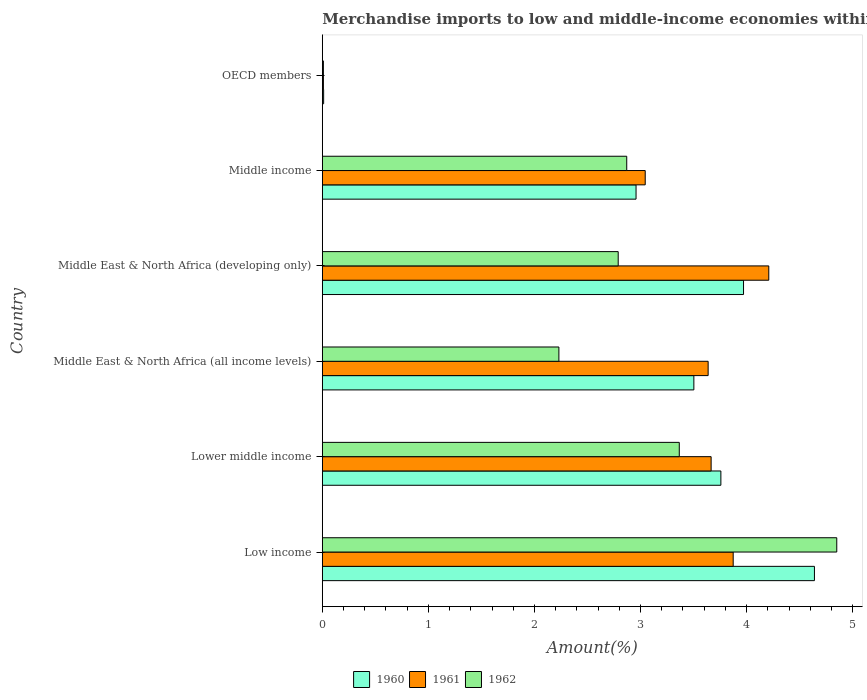How many different coloured bars are there?
Keep it short and to the point. 3. How many groups of bars are there?
Ensure brevity in your answer.  6. Are the number of bars on each tick of the Y-axis equal?
Ensure brevity in your answer.  Yes. How many bars are there on the 2nd tick from the top?
Offer a terse response. 3. In how many cases, is the number of bars for a given country not equal to the number of legend labels?
Give a very brief answer. 0. What is the percentage of amount earned from merchandise imports in 1962 in Lower middle income?
Ensure brevity in your answer.  3.37. Across all countries, what is the maximum percentage of amount earned from merchandise imports in 1960?
Your answer should be very brief. 4.64. Across all countries, what is the minimum percentage of amount earned from merchandise imports in 1960?
Ensure brevity in your answer.  0.01. In which country was the percentage of amount earned from merchandise imports in 1961 maximum?
Your response must be concise. Middle East & North Africa (developing only). In which country was the percentage of amount earned from merchandise imports in 1960 minimum?
Your response must be concise. OECD members. What is the total percentage of amount earned from merchandise imports in 1962 in the graph?
Make the answer very short. 16.11. What is the difference between the percentage of amount earned from merchandise imports in 1962 in Low income and that in OECD members?
Provide a short and direct response. 4.84. What is the difference between the percentage of amount earned from merchandise imports in 1961 in Middle East & North Africa (developing only) and the percentage of amount earned from merchandise imports in 1962 in OECD members?
Your answer should be very brief. 4.2. What is the average percentage of amount earned from merchandise imports in 1962 per country?
Make the answer very short. 2.69. What is the difference between the percentage of amount earned from merchandise imports in 1960 and percentage of amount earned from merchandise imports in 1962 in Lower middle income?
Your answer should be very brief. 0.39. What is the ratio of the percentage of amount earned from merchandise imports in 1962 in Lower middle income to that in Middle East & North Africa (developing only)?
Give a very brief answer. 1.21. Is the percentage of amount earned from merchandise imports in 1962 in Low income less than that in Middle East & North Africa (all income levels)?
Your answer should be very brief. No. What is the difference between the highest and the second highest percentage of amount earned from merchandise imports in 1960?
Keep it short and to the point. 0.67. What is the difference between the highest and the lowest percentage of amount earned from merchandise imports in 1961?
Keep it short and to the point. 4.2. Is the sum of the percentage of amount earned from merchandise imports in 1960 in Middle East & North Africa (all income levels) and OECD members greater than the maximum percentage of amount earned from merchandise imports in 1961 across all countries?
Ensure brevity in your answer.  No. Is it the case that in every country, the sum of the percentage of amount earned from merchandise imports in 1962 and percentage of amount earned from merchandise imports in 1961 is greater than the percentage of amount earned from merchandise imports in 1960?
Ensure brevity in your answer.  Yes. How many bars are there?
Your response must be concise. 18. Are all the bars in the graph horizontal?
Make the answer very short. Yes. How many countries are there in the graph?
Ensure brevity in your answer.  6. What is the difference between two consecutive major ticks on the X-axis?
Your answer should be very brief. 1. Does the graph contain grids?
Ensure brevity in your answer.  No. How many legend labels are there?
Provide a short and direct response. 3. What is the title of the graph?
Give a very brief answer. Merchandise imports to low and middle-income economies within region. What is the label or title of the X-axis?
Provide a short and direct response. Amount(%). What is the label or title of the Y-axis?
Provide a short and direct response. Country. What is the Amount(%) of 1960 in Low income?
Provide a short and direct response. 4.64. What is the Amount(%) of 1961 in Low income?
Make the answer very short. 3.87. What is the Amount(%) in 1962 in Low income?
Provide a succinct answer. 4.85. What is the Amount(%) of 1960 in Lower middle income?
Ensure brevity in your answer.  3.76. What is the Amount(%) of 1961 in Lower middle income?
Provide a succinct answer. 3.67. What is the Amount(%) of 1962 in Lower middle income?
Provide a succinct answer. 3.37. What is the Amount(%) in 1960 in Middle East & North Africa (all income levels)?
Give a very brief answer. 3.5. What is the Amount(%) in 1961 in Middle East & North Africa (all income levels)?
Offer a terse response. 3.64. What is the Amount(%) in 1962 in Middle East & North Africa (all income levels)?
Make the answer very short. 2.23. What is the Amount(%) of 1960 in Middle East & North Africa (developing only)?
Your answer should be compact. 3.97. What is the Amount(%) in 1961 in Middle East & North Africa (developing only)?
Your response must be concise. 4.21. What is the Amount(%) in 1962 in Middle East & North Africa (developing only)?
Provide a succinct answer. 2.79. What is the Amount(%) in 1960 in Middle income?
Offer a very short reply. 2.96. What is the Amount(%) of 1961 in Middle income?
Your answer should be compact. 3.04. What is the Amount(%) in 1962 in Middle income?
Provide a short and direct response. 2.87. What is the Amount(%) of 1960 in OECD members?
Your answer should be compact. 0.01. What is the Amount(%) in 1961 in OECD members?
Provide a succinct answer. 0.01. What is the Amount(%) of 1962 in OECD members?
Make the answer very short. 0.01. Across all countries, what is the maximum Amount(%) of 1960?
Offer a terse response. 4.64. Across all countries, what is the maximum Amount(%) of 1961?
Ensure brevity in your answer.  4.21. Across all countries, what is the maximum Amount(%) in 1962?
Provide a succinct answer. 4.85. Across all countries, what is the minimum Amount(%) in 1960?
Make the answer very short. 0.01. Across all countries, what is the minimum Amount(%) in 1961?
Your response must be concise. 0.01. Across all countries, what is the minimum Amount(%) of 1962?
Make the answer very short. 0.01. What is the total Amount(%) in 1960 in the graph?
Provide a short and direct response. 18.84. What is the total Amount(%) of 1961 in the graph?
Your response must be concise. 18.44. What is the total Amount(%) of 1962 in the graph?
Ensure brevity in your answer.  16.11. What is the difference between the Amount(%) in 1960 in Low income and that in Lower middle income?
Keep it short and to the point. 0.88. What is the difference between the Amount(%) in 1961 in Low income and that in Lower middle income?
Your answer should be compact. 0.21. What is the difference between the Amount(%) of 1962 in Low income and that in Lower middle income?
Keep it short and to the point. 1.48. What is the difference between the Amount(%) in 1960 in Low income and that in Middle East & North Africa (all income levels)?
Your answer should be compact. 1.14. What is the difference between the Amount(%) in 1961 in Low income and that in Middle East & North Africa (all income levels)?
Provide a succinct answer. 0.24. What is the difference between the Amount(%) of 1962 in Low income and that in Middle East & North Africa (all income levels)?
Your answer should be compact. 2.62. What is the difference between the Amount(%) of 1960 in Low income and that in Middle East & North Africa (developing only)?
Your answer should be very brief. 0.67. What is the difference between the Amount(%) in 1961 in Low income and that in Middle East & North Africa (developing only)?
Your response must be concise. -0.34. What is the difference between the Amount(%) in 1962 in Low income and that in Middle East & North Africa (developing only)?
Provide a short and direct response. 2.06. What is the difference between the Amount(%) in 1960 in Low income and that in Middle income?
Provide a succinct answer. 1.68. What is the difference between the Amount(%) of 1961 in Low income and that in Middle income?
Provide a short and direct response. 0.83. What is the difference between the Amount(%) in 1962 in Low income and that in Middle income?
Offer a terse response. 1.98. What is the difference between the Amount(%) in 1960 in Low income and that in OECD members?
Offer a very short reply. 4.63. What is the difference between the Amount(%) in 1961 in Low income and that in OECD members?
Make the answer very short. 3.86. What is the difference between the Amount(%) in 1962 in Low income and that in OECD members?
Offer a terse response. 4.84. What is the difference between the Amount(%) of 1960 in Lower middle income and that in Middle East & North Africa (all income levels)?
Offer a very short reply. 0.25. What is the difference between the Amount(%) of 1961 in Lower middle income and that in Middle East & North Africa (all income levels)?
Ensure brevity in your answer.  0.03. What is the difference between the Amount(%) of 1962 in Lower middle income and that in Middle East & North Africa (all income levels)?
Offer a terse response. 1.14. What is the difference between the Amount(%) of 1960 in Lower middle income and that in Middle East & North Africa (developing only)?
Your response must be concise. -0.21. What is the difference between the Amount(%) in 1961 in Lower middle income and that in Middle East & North Africa (developing only)?
Keep it short and to the point. -0.54. What is the difference between the Amount(%) of 1962 in Lower middle income and that in Middle East & North Africa (developing only)?
Your answer should be very brief. 0.58. What is the difference between the Amount(%) of 1960 in Lower middle income and that in Middle income?
Your answer should be very brief. 0.8. What is the difference between the Amount(%) of 1961 in Lower middle income and that in Middle income?
Make the answer very short. 0.62. What is the difference between the Amount(%) in 1962 in Lower middle income and that in Middle income?
Your answer should be very brief. 0.5. What is the difference between the Amount(%) in 1960 in Lower middle income and that in OECD members?
Your answer should be compact. 3.75. What is the difference between the Amount(%) in 1961 in Lower middle income and that in OECD members?
Provide a succinct answer. 3.66. What is the difference between the Amount(%) in 1962 in Lower middle income and that in OECD members?
Your answer should be compact. 3.36. What is the difference between the Amount(%) of 1960 in Middle East & North Africa (all income levels) and that in Middle East & North Africa (developing only)?
Your answer should be compact. -0.47. What is the difference between the Amount(%) in 1961 in Middle East & North Africa (all income levels) and that in Middle East & North Africa (developing only)?
Ensure brevity in your answer.  -0.57. What is the difference between the Amount(%) of 1962 in Middle East & North Africa (all income levels) and that in Middle East & North Africa (developing only)?
Offer a terse response. -0.56. What is the difference between the Amount(%) in 1960 in Middle East & North Africa (all income levels) and that in Middle income?
Your answer should be very brief. 0.55. What is the difference between the Amount(%) in 1961 in Middle East & North Africa (all income levels) and that in Middle income?
Give a very brief answer. 0.59. What is the difference between the Amount(%) in 1962 in Middle East & North Africa (all income levels) and that in Middle income?
Keep it short and to the point. -0.64. What is the difference between the Amount(%) of 1960 in Middle East & North Africa (all income levels) and that in OECD members?
Provide a short and direct response. 3.49. What is the difference between the Amount(%) in 1961 in Middle East & North Africa (all income levels) and that in OECD members?
Keep it short and to the point. 3.63. What is the difference between the Amount(%) of 1962 in Middle East & North Africa (all income levels) and that in OECD members?
Your response must be concise. 2.22. What is the difference between the Amount(%) of 1960 in Middle East & North Africa (developing only) and that in Middle income?
Your response must be concise. 1.01. What is the difference between the Amount(%) in 1961 in Middle East & North Africa (developing only) and that in Middle income?
Your answer should be compact. 1.16. What is the difference between the Amount(%) of 1962 in Middle East & North Africa (developing only) and that in Middle income?
Ensure brevity in your answer.  -0.08. What is the difference between the Amount(%) of 1960 in Middle East & North Africa (developing only) and that in OECD members?
Your response must be concise. 3.96. What is the difference between the Amount(%) of 1961 in Middle East & North Africa (developing only) and that in OECD members?
Offer a very short reply. 4.2. What is the difference between the Amount(%) in 1962 in Middle East & North Africa (developing only) and that in OECD members?
Give a very brief answer. 2.78. What is the difference between the Amount(%) of 1960 in Middle income and that in OECD members?
Provide a short and direct response. 2.95. What is the difference between the Amount(%) of 1961 in Middle income and that in OECD members?
Your answer should be compact. 3.03. What is the difference between the Amount(%) of 1962 in Middle income and that in OECD members?
Give a very brief answer. 2.86. What is the difference between the Amount(%) of 1960 in Low income and the Amount(%) of 1961 in Lower middle income?
Ensure brevity in your answer.  0.97. What is the difference between the Amount(%) of 1960 in Low income and the Amount(%) of 1962 in Lower middle income?
Your response must be concise. 1.27. What is the difference between the Amount(%) of 1961 in Low income and the Amount(%) of 1962 in Lower middle income?
Your response must be concise. 0.51. What is the difference between the Amount(%) in 1960 in Low income and the Amount(%) in 1962 in Middle East & North Africa (all income levels)?
Provide a succinct answer. 2.41. What is the difference between the Amount(%) in 1961 in Low income and the Amount(%) in 1962 in Middle East & North Africa (all income levels)?
Ensure brevity in your answer.  1.64. What is the difference between the Amount(%) in 1960 in Low income and the Amount(%) in 1961 in Middle East & North Africa (developing only)?
Provide a short and direct response. 0.43. What is the difference between the Amount(%) of 1960 in Low income and the Amount(%) of 1962 in Middle East & North Africa (developing only)?
Your answer should be very brief. 1.85. What is the difference between the Amount(%) in 1961 in Low income and the Amount(%) in 1962 in Middle East & North Africa (developing only)?
Your answer should be compact. 1.08. What is the difference between the Amount(%) in 1960 in Low income and the Amount(%) in 1961 in Middle income?
Provide a short and direct response. 1.6. What is the difference between the Amount(%) in 1960 in Low income and the Amount(%) in 1962 in Middle income?
Make the answer very short. 1.77. What is the difference between the Amount(%) in 1960 in Low income and the Amount(%) in 1961 in OECD members?
Ensure brevity in your answer.  4.63. What is the difference between the Amount(%) of 1960 in Low income and the Amount(%) of 1962 in OECD members?
Provide a short and direct response. 4.63. What is the difference between the Amount(%) of 1961 in Low income and the Amount(%) of 1962 in OECD members?
Keep it short and to the point. 3.86. What is the difference between the Amount(%) in 1960 in Lower middle income and the Amount(%) in 1961 in Middle East & North Africa (all income levels)?
Keep it short and to the point. 0.12. What is the difference between the Amount(%) of 1960 in Lower middle income and the Amount(%) of 1962 in Middle East & North Africa (all income levels)?
Your answer should be very brief. 1.53. What is the difference between the Amount(%) of 1961 in Lower middle income and the Amount(%) of 1962 in Middle East & North Africa (all income levels)?
Keep it short and to the point. 1.44. What is the difference between the Amount(%) in 1960 in Lower middle income and the Amount(%) in 1961 in Middle East & North Africa (developing only)?
Your response must be concise. -0.45. What is the difference between the Amount(%) in 1960 in Lower middle income and the Amount(%) in 1962 in Middle East & North Africa (developing only)?
Your answer should be compact. 0.97. What is the difference between the Amount(%) in 1961 in Lower middle income and the Amount(%) in 1962 in Middle East & North Africa (developing only)?
Offer a terse response. 0.88. What is the difference between the Amount(%) in 1960 in Lower middle income and the Amount(%) in 1961 in Middle income?
Make the answer very short. 0.71. What is the difference between the Amount(%) of 1960 in Lower middle income and the Amount(%) of 1962 in Middle income?
Give a very brief answer. 0.89. What is the difference between the Amount(%) in 1961 in Lower middle income and the Amount(%) in 1962 in Middle income?
Ensure brevity in your answer.  0.8. What is the difference between the Amount(%) in 1960 in Lower middle income and the Amount(%) in 1961 in OECD members?
Your answer should be very brief. 3.75. What is the difference between the Amount(%) in 1960 in Lower middle income and the Amount(%) in 1962 in OECD members?
Your response must be concise. 3.75. What is the difference between the Amount(%) of 1961 in Lower middle income and the Amount(%) of 1962 in OECD members?
Offer a very short reply. 3.66. What is the difference between the Amount(%) of 1960 in Middle East & North Africa (all income levels) and the Amount(%) of 1961 in Middle East & North Africa (developing only)?
Provide a short and direct response. -0.71. What is the difference between the Amount(%) of 1960 in Middle East & North Africa (all income levels) and the Amount(%) of 1962 in Middle East & North Africa (developing only)?
Ensure brevity in your answer.  0.71. What is the difference between the Amount(%) of 1961 in Middle East & North Africa (all income levels) and the Amount(%) of 1962 in Middle East & North Africa (developing only)?
Your answer should be very brief. 0.85. What is the difference between the Amount(%) of 1960 in Middle East & North Africa (all income levels) and the Amount(%) of 1961 in Middle income?
Ensure brevity in your answer.  0.46. What is the difference between the Amount(%) of 1960 in Middle East & North Africa (all income levels) and the Amount(%) of 1962 in Middle income?
Your answer should be very brief. 0.63. What is the difference between the Amount(%) in 1961 in Middle East & North Africa (all income levels) and the Amount(%) in 1962 in Middle income?
Provide a succinct answer. 0.77. What is the difference between the Amount(%) in 1960 in Middle East & North Africa (all income levels) and the Amount(%) in 1961 in OECD members?
Offer a terse response. 3.49. What is the difference between the Amount(%) in 1960 in Middle East & North Africa (all income levels) and the Amount(%) in 1962 in OECD members?
Make the answer very short. 3.49. What is the difference between the Amount(%) in 1961 in Middle East & North Africa (all income levels) and the Amount(%) in 1962 in OECD members?
Offer a very short reply. 3.63. What is the difference between the Amount(%) of 1960 in Middle East & North Africa (developing only) and the Amount(%) of 1961 in Middle income?
Offer a very short reply. 0.93. What is the difference between the Amount(%) of 1960 in Middle East & North Africa (developing only) and the Amount(%) of 1962 in Middle income?
Ensure brevity in your answer.  1.1. What is the difference between the Amount(%) in 1961 in Middle East & North Africa (developing only) and the Amount(%) in 1962 in Middle income?
Your response must be concise. 1.34. What is the difference between the Amount(%) in 1960 in Middle East & North Africa (developing only) and the Amount(%) in 1961 in OECD members?
Keep it short and to the point. 3.96. What is the difference between the Amount(%) of 1960 in Middle East & North Africa (developing only) and the Amount(%) of 1962 in OECD members?
Offer a very short reply. 3.96. What is the difference between the Amount(%) in 1961 in Middle East & North Africa (developing only) and the Amount(%) in 1962 in OECD members?
Your answer should be very brief. 4.2. What is the difference between the Amount(%) in 1960 in Middle income and the Amount(%) in 1961 in OECD members?
Ensure brevity in your answer.  2.95. What is the difference between the Amount(%) in 1960 in Middle income and the Amount(%) in 1962 in OECD members?
Keep it short and to the point. 2.95. What is the difference between the Amount(%) of 1961 in Middle income and the Amount(%) of 1962 in OECD members?
Provide a short and direct response. 3.03. What is the average Amount(%) in 1960 per country?
Your response must be concise. 3.14. What is the average Amount(%) in 1961 per country?
Offer a very short reply. 3.07. What is the average Amount(%) in 1962 per country?
Your response must be concise. 2.69. What is the difference between the Amount(%) of 1960 and Amount(%) of 1961 in Low income?
Give a very brief answer. 0.77. What is the difference between the Amount(%) in 1960 and Amount(%) in 1962 in Low income?
Make the answer very short. -0.21. What is the difference between the Amount(%) in 1961 and Amount(%) in 1962 in Low income?
Give a very brief answer. -0.98. What is the difference between the Amount(%) of 1960 and Amount(%) of 1961 in Lower middle income?
Your answer should be compact. 0.09. What is the difference between the Amount(%) of 1960 and Amount(%) of 1962 in Lower middle income?
Ensure brevity in your answer.  0.39. What is the difference between the Amount(%) of 1961 and Amount(%) of 1962 in Lower middle income?
Make the answer very short. 0.3. What is the difference between the Amount(%) in 1960 and Amount(%) in 1961 in Middle East & North Africa (all income levels)?
Make the answer very short. -0.13. What is the difference between the Amount(%) of 1960 and Amount(%) of 1962 in Middle East & North Africa (all income levels)?
Your response must be concise. 1.27. What is the difference between the Amount(%) in 1961 and Amount(%) in 1962 in Middle East & North Africa (all income levels)?
Provide a succinct answer. 1.41. What is the difference between the Amount(%) of 1960 and Amount(%) of 1961 in Middle East & North Africa (developing only)?
Give a very brief answer. -0.24. What is the difference between the Amount(%) of 1960 and Amount(%) of 1962 in Middle East & North Africa (developing only)?
Give a very brief answer. 1.18. What is the difference between the Amount(%) in 1961 and Amount(%) in 1962 in Middle East & North Africa (developing only)?
Your answer should be very brief. 1.42. What is the difference between the Amount(%) in 1960 and Amount(%) in 1961 in Middle income?
Provide a succinct answer. -0.09. What is the difference between the Amount(%) in 1960 and Amount(%) in 1962 in Middle income?
Your answer should be very brief. 0.09. What is the difference between the Amount(%) of 1961 and Amount(%) of 1962 in Middle income?
Ensure brevity in your answer.  0.17. What is the difference between the Amount(%) in 1960 and Amount(%) in 1961 in OECD members?
Make the answer very short. 0. What is the difference between the Amount(%) of 1960 and Amount(%) of 1962 in OECD members?
Your response must be concise. 0. What is the difference between the Amount(%) of 1961 and Amount(%) of 1962 in OECD members?
Make the answer very short. 0. What is the ratio of the Amount(%) in 1960 in Low income to that in Lower middle income?
Provide a succinct answer. 1.23. What is the ratio of the Amount(%) in 1961 in Low income to that in Lower middle income?
Offer a very short reply. 1.06. What is the ratio of the Amount(%) of 1962 in Low income to that in Lower middle income?
Make the answer very short. 1.44. What is the ratio of the Amount(%) of 1960 in Low income to that in Middle East & North Africa (all income levels)?
Provide a succinct answer. 1.32. What is the ratio of the Amount(%) in 1961 in Low income to that in Middle East & North Africa (all income levels)?
Provide a short and direct response. 1.06. What is the ratio of the Amount(%) in 1962 in Low income to that in Middle East & North Africa (all income levels)?
Provide a succinct answer. 2.17. What is the ratio of the Amount(%) of 1960 in Low income to that in Middle East & North Africa (developing only)?
Your response must be concise. 1.17. What is the ratio of the Amount(%) in 1961 in Low income to that in Middle East & North Africa (developing only)?
Offer a very short reply. 0.92. What is the ratio of the Amount(%) in 1962 in Low income to that in Middle East & North Africa (developing only)?
Provide a short and direct response. 1.74. What is the ratio of the Amount(%) of 1960 in Low income to that in Middle income?
Offer a terse response. 1.57. What is the ratio of the Amount(%) in 1961 in Low income to that in Middle income?
Your answer should be compact. 1.27. What is the ratio of the Amount(%) of 1962 in Low income to that in Middle income?
Your answer should be very brief. 1.69. What is the ratio of the Amount(%) of 1960 in Low income to that in OECD members?
Make the answer very short. 377.33. What is the ratio of the Amount(%) in 1961 in Low income to that in OECD members?
Offer a very short reply. 383.14. What is the ratio of the Amount(%) in 1962 in Low income to that in OECD members?
Offer a terse response. 483.73. What is the ratio of the Amount(%) of 1960 in Lower middle income to that in Middle East & North Africa (all income levels)?
Offer a very short reply. 1.07. What is the ratio of the Amount(%) of 1961 in Lower middle income to that in Middle East & North Africa (all income levels)?
Provide a short and direct response. 1.01. What is the ratio of the Amount(%) in 1962 in Lower middle income to that in Middle East & North Africa (all income levels)?
Your answer should be compact. 1.51. What is the ratio of the Amount(%) of 1960 in Lower middle income to that in Middle East & North Africa (developing only)?
Provide a succinct answer. 0.95. What is the ratio of the Amount(%) of 1961 in Lower middle income to that in Middle East & North Africa (developing only)?
Your answer should be compact. 0.87. What is the ratio of the Amount(%) of 1962 in Lower middle income to that in Middle East & North Africa (developing only)?
Your answer should be compact. 1.21. What is the ratio of the Amount(%) of 1960 in Lower middle income to that in Middle income?
Your response must be concise. 1.27. What is the ratio of the Amount(%) in 1961 in Lower middle income to that in Middle income?
Keep it short and to the point. 1.2. What is the ratio of the Amount(%) of 1962 in Lower middle income to that in Middle income?
Your response must be concise. 1.17. What is the ratio of the Amount(%) of 1960 in Lower middle income to that in OECD members?
Your answer should be very brief. 305.59. What is the ratio of the Amount(%) of 1961 in Lower middle income to that in OECD members?
Offer a terse response. 362.57. What is the ratio of the Amount(%) in 1962 in Lower middle income to that in OECD members?
Provide a succinct answer. 335.64. What is the ratio of the Amount(%) of 1960 in Middle East & North Africa (all income levels) to that in Middle East & North Africa (developing only)?
Offer a very short reply. 0.88. What is the ratio of the Amount(%) in 1961 in Middle East & North Africa (all income levels) to that in Middle East & North Africa (developing only)?
Provide a succinct answer. 0.86. What is the ratio of the Amount(%) in 1962 in Middle East & North Africa (all income levels) to that in Middle East & North Africa (developing only)?
Your response must be concise. 0.8. What is the ratio of the Amount(%) of 1960 in Middle East & North Africa (all income levels) to that in Middle income?
Give a very brief answer. 1.18. What is the ratio of the Amount(%) of 1961 in Middle East & North Africa (all income levels) to that in Middle income?
Your answer should be very brief. 1.19. What is the ratio of the Amount(%) of 1962 in Middle East & North Africa (all income levels) to that in Middle income?
Provide a short and direct response. 0.78. What is the ratio of the Amount(%) of 1960 in Middle East & North Africa (all income levels) to that in OECD members?
Offer a very short reply. 284.87. What is the ratio of the Amount(%) of 1961 in Middle East & North Africa (all income levels) to that in OECD members?
Your answer should be very brief. 359.78. What is the ratio of the Amount(%) in 1962 in Middle East & North Africa (all income levels) to that in OECD members?
Your answer should be compact. 222.44. What is the ratio of the Amount(%) of 1960 in Middle East & North Africa (developing only) to that in Middle income?
Offer a very short reply. 1.34. What is the ratio of the Amount(%) in 1961 in Middle East & North Africa (developing only) to that in Middle income?
Keep it short and to the point. 1.38. What is the ratio of the Amount(%) of 1962 in Middle East & North Africa (developing only) to that in Middle income?
Offer a terse response. 0.97. What is the ratio of the Amount(%) in 1960 in Middle East & North Africa (developing only) to that in OECD members?
Offer a terse response. 322.95. What is the ratio of the Amount(%) of 1961 in Middle East & North Africa (developing only) to that in OECD members?
Your answer should be compact. 416.33. What is the ratio of the Amount(%) in 1962 in Middle East & North Africa (developing only) to that in OECD members?
Your answer should be compact. 278.2. What is the ratio of the Amount(%) of 1960 in Middle income to that in OECD members?
Provide a short and direct response. 240.54. What is the ratio of the Amount(%) in 1961 in Middle income to that in OECD members?
Offer a very short reply. 301.11. What is the ratio of the Amount(%) in 1962 in Middle income to that in OECD members?
Make the answer very short. 286.23. What is the difference between the highest and the second highest Amount(%) of 1960?
Offer a terse response. 0.67. What is the difference between the highest and the second highest Amount(%) of 1961?
Your answer should be compact. 0.34. What is the difference between the highest and the second highest Amount(%) of 1962?
Provide a short and direct response. 1.48. What is the difference between the highest and the lowest Amount(%) of 1960?
Your response must be concise. 4.63. What is the difference between the highest and the lowest Amount(%) in 1961?
Provide a succinct answer. 4.2. What is the difference between the highest and the lowest Amount(%) of 1962?
Provide a short and direct response. 4.84. 